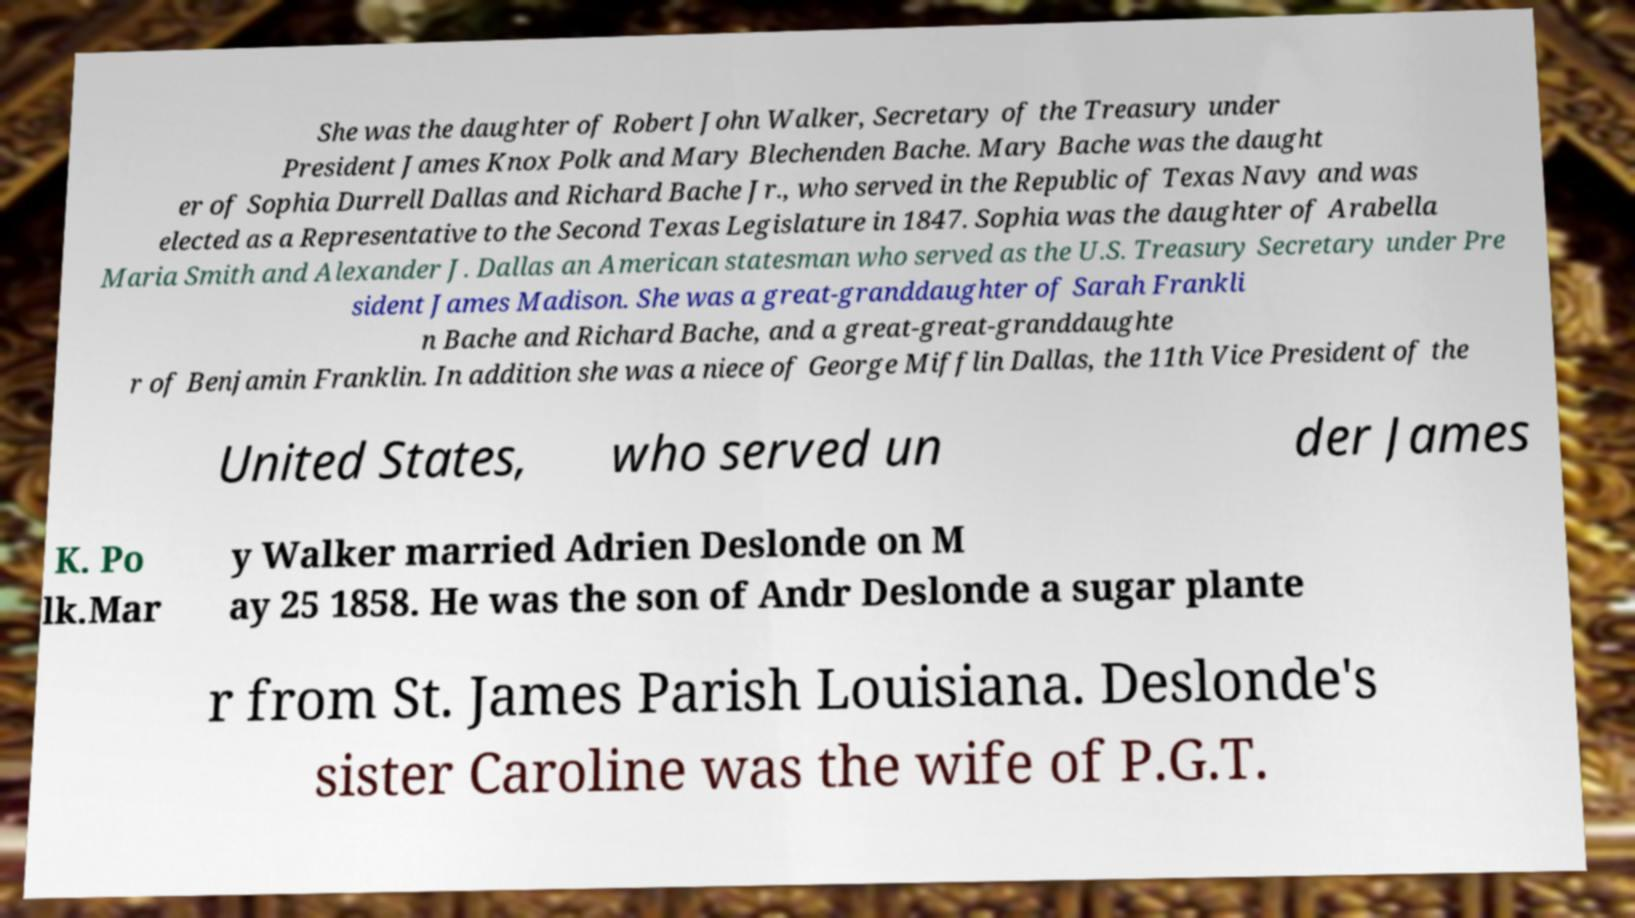Could you assist in decoding the text presented in this image and type it out clearly? She was the daughter of Robert John Walker, Secretary of the Treasury under President James Knox Polk and Mary Blechenden Bache. Mary Bache was the daught er of Sophia Durrell Dallas and Richard Bache Jr., who served in the Republic of Texas Navy and was elected as a Representative to the Second Texas Legislature in 1847. Sophia was the daughter of Arabella Maria Smith and Alexander J. Dallas an American statesman who served as the U.S. Treasury Secretary under Pre sident James Madison. She was a great-granddaughter of Sarah Frankli n Bache and Richard Bache, and a great-great-granddaughte r of Benjamin Franklin. In addition she was a niece of George Mifflin Dallas, the 11th Vice President of the United States, who served un der James K. Po lk.Mar y Walker married Adrien Deslonde on M ay 25 1858. He was the son of Andr Deslonde a sugar plante r from St. James Parish Louisiana. Deslonde's sister Caroline was the wife of P.G.T. 